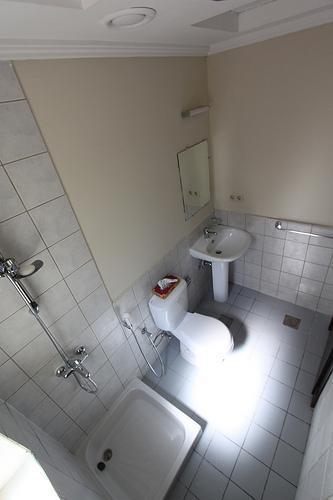How many lights are there?
Give a very brief answer. 1. 